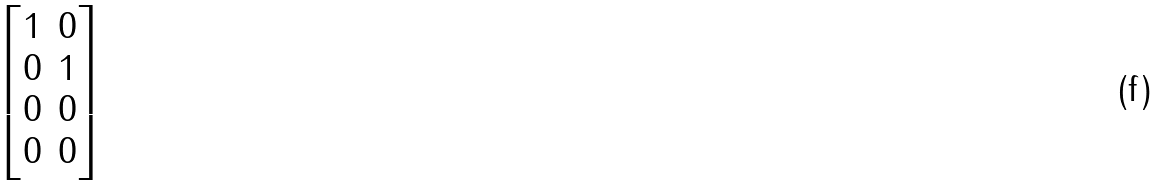Convert formula to latex. <formula><loc_0><loc_0><loc_500><loc_500>\begin{bmatrix} 1 & 0 \\ 0 & 1 \\ 0 & 0 \\ 0 & 0 \end{bmatrix}</formula> 